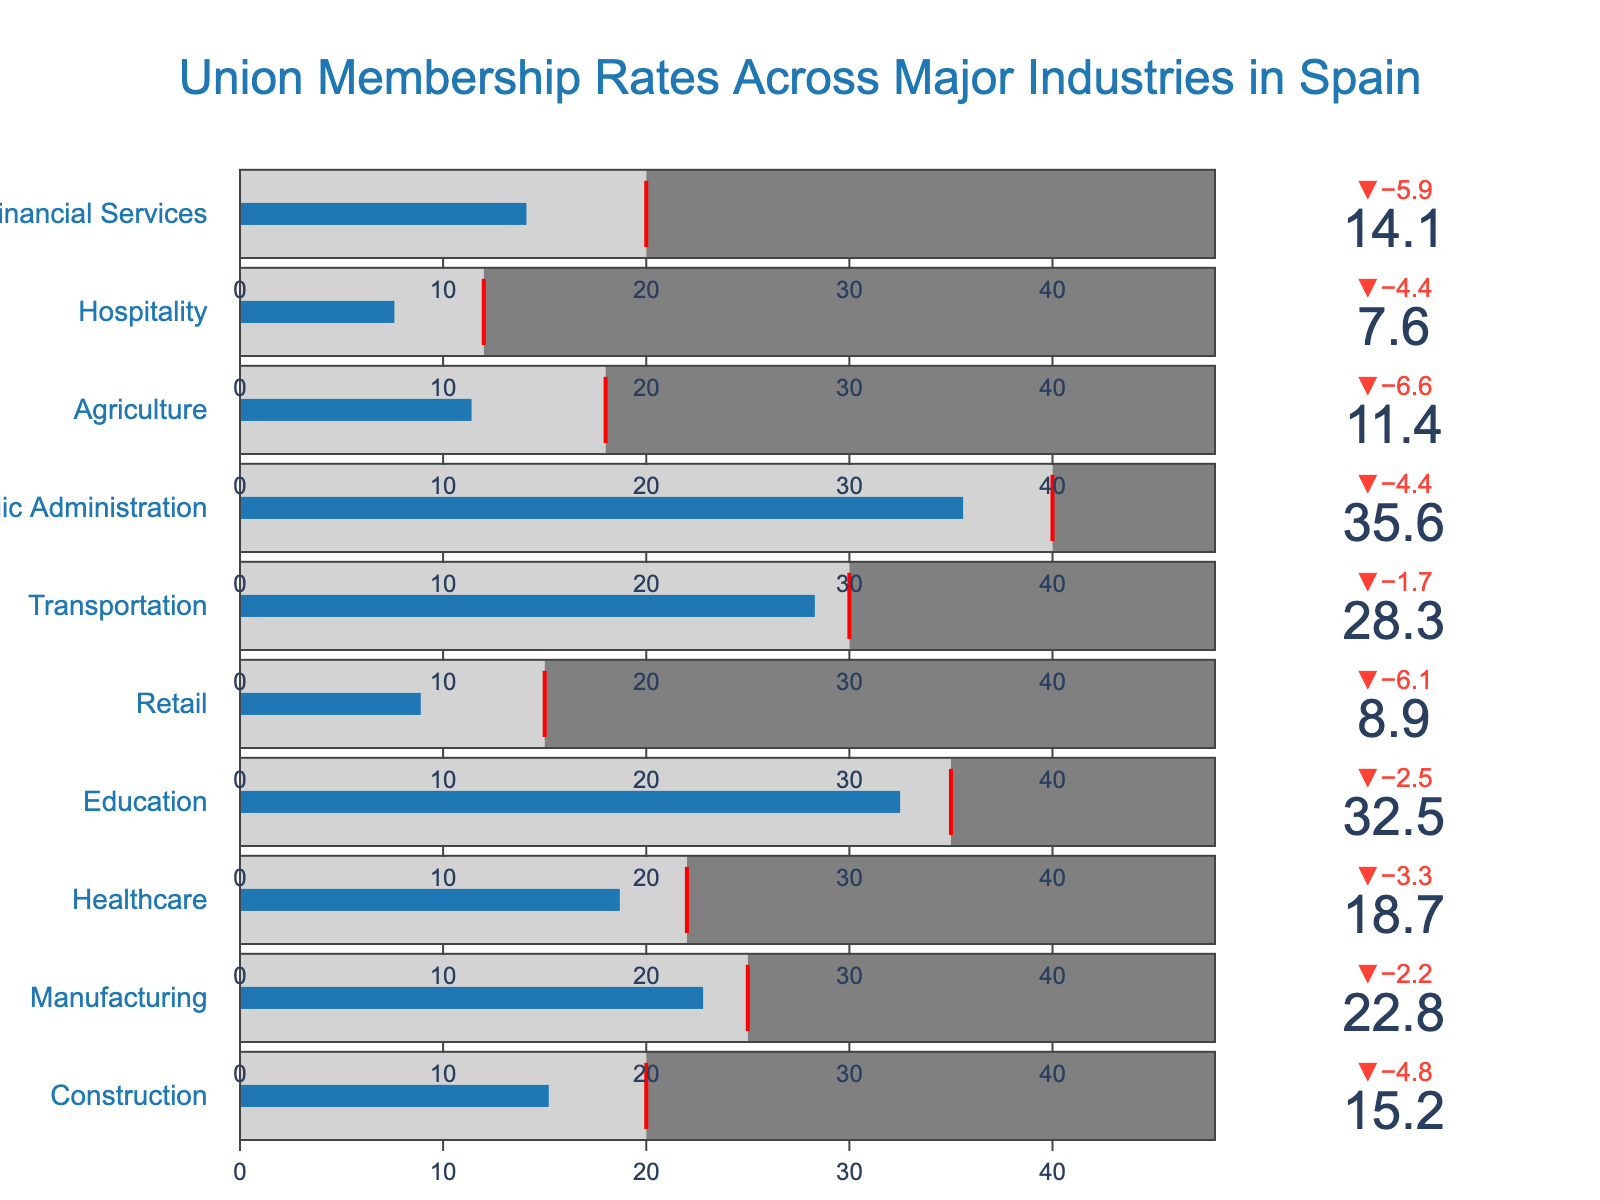Which industry has the highest actual union membership rate? By examining the bullet chart, identify which industry's bar extends furthest to the right on the actual membership rate scale.
Answer: Public Administration What's the difference between the actual membership rate and the target rate for the Healthcare industry? Find the target rate and actual membership rate values for Healthcare, then subtract the actual rate from the target rate: 22 - 18.7.
Answer: 3.3 Which industry has the smallest actual membership rate compared to its target rate? Compare the difference between the actual and target rates for each industry and identify the one with the biggest gap. Hospitality has the widest gap: 12 - 7.6.
Answer: Hospitality What is the overall trend of actual union membership rates compared to their respective target rates across these industries? Check if the actual rates generally fall below, above, or match the target rates by visually comparing the bar lengths to the threshold markers for each industry.
Answer: Below target How many industries have an actual membership rate above 20%? Count the number of industries where the bar exceeds the 20% mark. These include Manufacturing, Education, Transportation, and Public Administration, resulting in four industries.
Answer: 4 In which industry is the actual union membership rate closest to its target? Determine the differences between the actual and target rates for each industry and find the one with the smallest difference. Transportation has a difference of 1.7: 30 - 28.3.
Answer: Transportation What is the median actual membership rate across all industries? List the actual membership rates in ascending order and find the middle value: [7.6, 8.9, 11.4, 14.1, 15.2, 18.7, 22.8, 28.3, 32.5, 35.6]. The median is the middle value for an odd number of data points (18.7).
Answer: 18.7 What similarities do you observe in the actual membership rates for the Construction and Financial Services industries? Compare the actual membership rates visually for similarities. Both rates lie in the range of 15-15.2%.
Answer: Both are around 15% Which industry shows the largest deviation of actual union membership rate from the target rate? Identify the difference between actual and target rates for each industry and find the largest deviation. Public Administration has the largest deviation of 4.4 (40 - 35.6).
Answer: Public Administration 